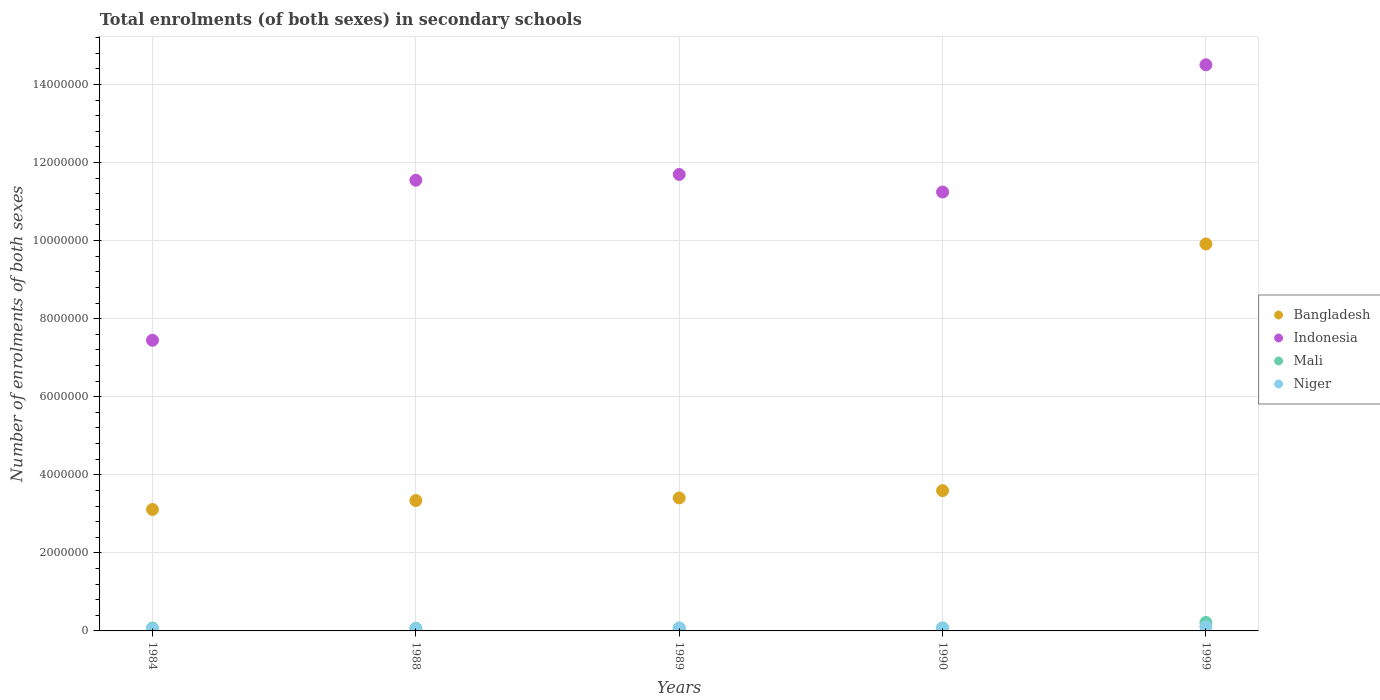How many different coloured dotlines are there?
Your answer should be very brief. 4. What is the number of enrolments in secondary schools in Indonesia in 1988?
Your answer should be very brief. 1.15e+07. Across all years, what is the maximum number of enrolments in secondary schools in Mali?
Provide a succinct answer. 2.18e+05. Across all years, what is the minimum number of enrolments in secondary schools in Bangladesh?
Ensure brevity in your answer.  3.11e+06. What is the total number of enrolments in secondary schools in Niger in the graph?
Offer a very short reply. 3.45e+05. What is the difference between the number of enrolments in secondary schools in Indonesia in 1988 and that in 1999?
Your response must be concise. -2.96e+06. What is the difference between the number of enrolments in secondary schools in Bangladesh in 1988 and the number of enrolments in secondary schools in Niger in 1989?
Give a very brief answer. 3.27e+06. What is the average number of enrolments in secondary schools in Indonesia per year?
Offer a very short reply. 1.13e+07. In the year 1984, what is the difference between the number of enrolments in secondary schools in Mali and number of enrolments in secondary schools in Indonesia?
Give a very brief answer. -7.37e+06. In how many years, is the number of enrolments in secondary schools in Indonesia greater than 12800000?
Offer a very short reply. 1. What is the ratio of the number of enrolments in secondary schools in Niger in 1984 to that in 1999?
Offer a very short reply. 0.45. Is the number of enrolments in secondary schools in Bangladesh in 1984 less than that in 1999?
Provide a succinct answer. Yes. Is the difference between the number of enrolments in secondary schools in Mali in 1990 and 1999 greater than the difference between the number of enrolments in secondary schools in Indonesia in 1990 and 1999?
Your answer should be compact. Yes. What is the difference between the highest and the second highest number of enrolments in secondary schools in Bangladesh?
Offer a terse response. 6.32e+06. What is the difference between the highest and the lowest number of enrolments in secondary schools in Mali?
Provide a succinct answer. 1.51e+05. Is the sum of the number of enrolments in secondary schools in Mali in 1988 and 1999 greater than the maximum number of enrolments in secondary schools in Bangladesh across all years?
Your answer should be very brief. No. Is the number of enrolments in secondary schools in Mali strictly greater than the number of enrolments in secondary schools in Niger over the years?
Ensure brevity in your answer.  Yes. How many dotlines are there?
Provide a succinct answer. 4. What is the difference between two consecutive major ticks on the Y-axis?
Provide a succinct answer. 2.00e+06. Does the graph contain grids?
Provide a short and direct response. Yes. Where does the legend appear in the graph?
Your response must be concise. Center right. How many legend labels are there?
Provide a succinct answer. 4. What is the title of the graph?
Provide a succinct answer. Total enrolments (of both sexes) in secondary schools. Does "Argentina" appear as one of the legend labels in the graph?
Provide a short and direct response. No. What is the label or title of the X-axis?
Offer a very short reply. Years. What is the label or title of the Y-axis?
Provide a short and direct response. Number of enrolments of both sexes. What is the Number of enrolments of both sexes of Bangladesh in 1984?
Give a very brief answer. 3.11e+06. What is the Number of enrolments of both sexes of Indonesia in 1984?
Keep it short and to the point. 7.45e+06. What is the Number of enrolments of both sexes in Mali in 1984?
Your answer should be very brief. 7.32e+04. What is the Number of enrolments of both sexes of Niger in 1984?
Keep it short and to the point. 4.72e+04. What is the Number of enrolments of both sexes in Bangladesh in 1988?
Provide a succinct answer. 3.34e+06. What is the Number of enrolments of both sexes in Indonesia in 1988?
Your answer should be very brief. 1.15e+07. What is the Number of enrolments of both sexes of Mali in 1988?
Give a very brief answer. 6.64e+04. What is the Number of enrolments of both sexes of Niger in 1988?
Ensure brevity in your answer.  5.85e+04. What is the Number of enrolments of both sexes of Bangladesh in 1989?
Ensure brevity in your answer.  3.41e+06. What is the Number of enrolments of both sexes of Indonesia in 1989?
Ensure brevity in your answer.  1.17e+07. What is the Number of enrolments of both sexes in Mali in 1989?
Offer a terse response. 7.52e+04. What is the Number of enrolments of both sexes in Niger in 1989?
Offer a terse response. 6.58e+04. What is the Number of enrolments of both sexes of Bangladesh in 1990?
Your answer should be very brief. 3.59e+06. What is the Number of enrolments of both sexes of Indonesia in 1990?
Your answer should be very brief. 1.12e+07. What is the Number of enrolments of both sexes of Mali in 1990?
Provide a short and direct response. 7.65e+04. What is the Number of enrolments of both sexes in Niger in 1990?
Your response must be concise. 6.84e+04. What is the Number of enrolments of both sexes in Bangladesh in 1999?
Offer a very short reply. 9.91e+06. What is the Number of enrolments of both sexes in Indonesia in 1999?
Offer a very short reply. 1.45e+07. What is the Number of enrolments of both sexes of Mali in 1999?
Keep it short and to the point. 2.18e+05. What is the Number of enrolments of both sexes in Niger in 1999?
Provide a short and direct response. 1.05e+05. Across all years, what is the maximum Number of enrolments of both sexes of Bangladesh?
Provide a succinct answer. 9.91e+06. Across all years, what is the maximum Number of enrolments of both sexes in Indonesia?
Provide a short and direct response. 1.45e+07. Across all years, what is the maximum Number of enrolments of both sexes of Mali?
Keep it short and to the point. 2.18e+05. Across all years, what is the maximum Number of enrolments of both sexes in Niger?
Give a very brief answer. 1.05e+05. Across all years, what is the minimum Number of enrolments of both sexes of Bangladesh?
Your answer should be very brief. 3.11e+06. Across all years, what is the minimum Number of enrolments of both sexes of Indonesia?
Ensure brevity in your answer.  7.45e+06. Across all years, what is the minimum Number of enrolments of both sexes in Mali?
Your response must be concise. 6.64e+04. Across all years, what is the minimum Number of enrolments of both sexes in Niger?
Provide a short and direct response. 4.72e+04. What is the total Number of enrolments of both sexes of Bangladesh in the graph?
Your answer should be compact. 2.34e+07. What is the total Number of enrolments of both sexes of Indonesia in the graph?
Your response must be concise. 5.64e+07. What is the total Number of enrolments of both sexes in Mali in the graph?
Provide a succinct answer. 5.09e+05. What is the total Number of enrolments of both sexes in Niger in the graph?
Keep it short and to the point. 3.45e+05. What is the difference between the Number of enrolments of both sexes of Bangladesh in 1984 and that in 1988?
Keep it short and to the point. -2.29e+05. What is the difference between the Number of enrolments of both sexes in Indonesia in 1984 and that in 1988?
Ensure brevity in your answer.  -4.10e+06. What is the difference between the Number of enrolments of both sexes in Mali in 1984 and that in 1988?
Offer a terse response. 6787. What is the difference between the Number of enrolments of both sexes of Niger in 1984 and that in 1988?
Your response must be concise. -1.13e+04. What is the difference between the Number of enrolments of both sexes of Bangladesh in 1984 and that in 1989?
Offer a very short reply. -2.95e+05. What is the difference between the Number of enrolments of both sexes in Indonesia in 1984 and that in 1989?
Make the answer very short. -4.25e+06. What is the difference between the Number of enrolments of both sexes of Mali in 1984 and that in 1989?
Offer a terse response. -1995. What is the difference between the Number of enrolments of both sexes in Niger in 1984 and that in 1989?
Offer a very short reply. -1.86e+04. What is the difference between the Number of enrolments of both sexes of Bangladesh in 1984 and that in 1990?
Give a very brief answer. -4.82e+05. What is the difference between the Number of enrolments of both sexes of Indonesia in 1984 and that in 1990?
Keep it short and to the point. -3.80e+06. What is the difference between the Number of enrolments of both sexes of Mali in 1984 and that in 1990?
Make the answer very short. -3283. What is the difference between the Number of enrolments of both sexes of Niger in 1984 and that in 1990?
Provide a short and direct response. -2.12e+04. What is the difference between the Number of enrolments of both sexes of Bangladesh in 1984 and that in 1999?
Offer a terse response. -6.80e+06. What is the difference between the Number of enrolments of both sexes of Indonesia in 1984 and that in 1999?
Make the answer very short. -7.06e+06. What is the difference between the Number of enrolments of both sexes in Mali in 1984 and that in 1999?
Your response must be concise. -1.44e+05. What is the difference between the Number of enrolments of both sexes of Niger in 1984 and that in 1999?
Offer a terse response. -5.77e+04. What is the difference between the Number of enrolments of both sexes in Bangladesh in 1988 and that in 1989?
Your response must be concise. -6.64e+04. What is the difference between the Number of enrolments of both sexes of Indonesia in 1988 and that in 1989?
Your response must be concise. -1.48e+05. What is the difference between the Number of enrolments of both sexes in Mali in 1988 and that in 1989?
Provide a succinct answer. -8782. What is the difference between the Number of enrolments of both sexes in Niger in 1988 and that in 1989?
Keep it short and to the point. -7327. What is the difference between the Number of enrolments of both sexes in Bangladesh in 1988 and that in 1990?
Keep it short and to the point. -2.53e+05. What is the difference between the Number of enrolments of both sexes in Indonesia in 1988 and that in 1990?
Offer a terse response. 3.02e+05. What is the difference between the Number of enrolments of both sexes in Mali in 1988 and that in 1990?
Offer a very short reply. -1.01e+04. What is the difference between the Number of enrolments of both sexes of Niger in 1988 and that in 1990?
Your answer should be compact. -9863. What is the difference between the Number of enrolments of both sexes in Bangladesh in 1988 and that in 1999?
Provide a succinct answer. -6.57e+06. What is the difference between the Number of enrolments of both sexes of Indonesia in 1988 and that in 1999?
Ensure brevity in your answer.  -2.96e+06. What is the difference between the Number of enrolments of both sexes of Mali in 1988 and that in 1999?
Provide a short and direct response. -1.51e+05. What is the difference between the Number of enrolments of both sexes of Niger in 1988 and that in 1999?
Keep it short and to the point. -4.64e+04. What is the difference between the Number of enrolments of both sexes of Bangladesh in 1989 and that in 1990?
Provide a succinct answer. -1.86e+05. What is the difference between the Number of enrolments of both sexes in Indonesia in 1989 and that in 1990?
Provide a short and direct response. 4.50e+05. What is the difference between the Number of enrolments of both sexes of Mali in 1989 and that in 1990?
Provide a succinct answer. -1288. What is the difference between the Number of enrolments of both sexes of Niger in 1989 and that in 1990?
Offer a very short reply. -2536. What is the difference between the Number of enrolments of both sexes in Bangladesh in 1989 and that in 1999?
Make the answer very short. -6.51e+06. What is the difference between the Number of enrolments of both sexes of Indonesia in 1989 and that in 1999?
Give a very brief answer. -2.81e+06. What is the difference between the Number of enrolments of both sexes in Mali in 1989 and that in 1999?
Your answer should be compact. -1.42e+05. What is the difference between the Number of enrolments of both sexes in Niger in 1989 and that in 1999?
Your answer should be very brief. -3.91e+04. What is the difference between the Number of enrolments of both sexes in Bangladesh in 1990 and that in 1999?
Keep it short and to the point. -6.32e+06. What is the difference between the Number of enrolments of both sexes of Indonesia in 1990 and that in 1999?
Provide a succinct answer. -3.26e+06. What is the difference between the Number of enrolments of both sexes in Mali in 1990 and that in 1999?
Your answer should be compact. -1.41e+05. What is the difference between the Number of enrolments of both sexes in Niger in 1990 and that in 1999?
Provide a short and direct response. -3.66e+04. What is the difference between the Number of enrolments of both sexes of Bangladesh in 1984 and the Number of enrolments of both sexes of Indonesia in 1988?
Offer a very short reply. -8.43e+06. What is the difference between the Number of enrolments of both sexes of Bangladesh in 1984 and the Number of enrolments of both sexes of Mali in 1988?
Your response must be concise. 3.04e+06. What is the difference between the Number of enrolments of both sexes of Bangladesh in 1984 and the Number of enrolments of both sexes of Niger in 1988?
Ensure brevity in your answer.  3.05e+06. What is the difference between the Number of enrolments of both sexes of Indonesia in 1984 and the Number of enrolments of both sexes of Mali in 1988?
Provide a short and direct response. 7.38e+06. What is the difference between the Number of enrolments of both sexes of Indonesia in 1984 and the Number of enrolments of both sexes of Niger in 1988?
Your response must be concise. 7.39e+06. What is the difference between the Number of enrolments of both sexes in Mali in 1984 and the Number of enrolments of both sexes in Niger in 1988?
Offer a terse response. 1.47e+04. What is the difference between the Number of enrolments of both sexes in Bangladesh in 1984 and the Number of enrolments of both sexes in Indonesia in 1989?
Ensure brevity in your answer.  -8.58e+06. What is the difference between the Number of enrolments of both sexes of Bangladesh in 1984 and the Number of enrolments of both sexes of Mali in 1989?
Your answer should be very brief. 3.04e+06. What is the difference between the Number of enrolments of both sexes in Bangladesh in 1984 and the Number of enrolments of both sexes in Niger in 1989?
Your response must be concise. 3.05e+06. What is the difference between the Number of enrolments of both sexes in Indonesia in 1984 and the Number of enrolments of both sexes in Mali in 1989?
Keep it short and to the point. 7.37e+06. What is the difference between the Number of enrolments of both sexes in Indonesia in 1984 and the Number of enrolments of both sexes in Niger in 1989?
Your answer should be very brief. 7.38e+06. What is the difference between the Number of enrolments of both sexes in Mali in 1984 and the Number of enrolments of both sexes in Niger in 1989?
Your answer should be very brief. 7402. What is the difference between the Number of enrolments of both sexes in Bangladesh in 1984 and the Number of enrolments of both sexes in Indonesia in 1990?
Offer a very short reply. -8.13e+06. What is the difference between the Number of enrolments of both sexes of Bangladesh in 1984 and the Number of enrolments of both sexes of Mali in 1990?
Your answer should be compact. 3.03e+06. What is the difference between the Number of enrolments of both sexes in Bangladesh in 1984 and the Number of enrolments of both sexes in Niger in 1990?
Make the answer very short. 3.04e+06. What is the difference between the Number of enrolments of both sexes in Indonesia in 1984 and the Number of enrolments of both sexes in Mali in 1990?
Your response must be concise. 7.37e+06. What is the difference between the Number of enrolments of both sexes in Indonesia in 1984 and the Number of enrolments of both sexes in Niger in 1990?
Your answer should be compact. 7.38e+06. What is the difference between the Number of enrolments of both sexes of Mali in 1984 and the Number of enrolments of both sexes of Niger in 1990?
Your response must be concise. 4866. What is the difference between the Number of enrolments of both sexes in Bangladesh in 1984 and the Number of enrolments of both sexes in Indonesia in 1999?
Your answer should be very brief. -1.14e+07. What is the difference between the Number of enrolments of both sexes in Bangladesh in 1984 and the Number of enrolments of both sexes in Mali in 1999?
Provide a short and direct response. 2.89e+06. What is the difference between the Number of enrolments of both sexes of Bangladesh in 1984 and the Number of enrolments of both sexes of Niger in 1999?
Keep it short and to the point. 3.01e+06. What is the difference between the Number of enrolments of both sexes of Indonesia in 1984 and the Number of enrolments of both sexes of Mali in 1999?
Give a very brief answer. 7.23e+06. What is the difference between the Number of enrolments of both sexes in Indonesia in 1984 and the Number of enrolments of both sexes in Niger in 1999?
Offer a very short reply. 7.34e+06. What is the difference between the Number of enrolments of both sexes in Mali in 1984 and the Number of enrolments of both sexes in Niger in 1999?
Your answer should be very brief. -3.17e+04. What is the difference between the Number of enrolments of both sexes in Bangladesh in 1988 and the Number of enrolments of both sexes in Indonesia in 1989?
Keep it short and to the point. -8.35e+06. What is the difference between the Number of enrolments of both sexes in Bangladesh in 1988 and the Number of enrolments of both sexes in Mali in 1989?
Give a very brief answer. 3.26e+06. What is the difference between the Number of enrolments of both sexes in Bangladesh in 1988 and the Number of enrolments of both sexes in Niger in 1989?
Your answer should be very brief. 3.27e+06. What is the difference between the Number of enrolments of both sexes of Indonesia in 1988 and the Number of enrolments of both sexes of Mali in 1989?
Your answer should be compact. 1.15e+07. What is the difference between the Number of enrolments of both sexes of Indonesia in 1988 and the Number of enrolments of both sexes of Niger in 1989?
Provide a short and direct response. 1.15e+07. What is the difference between the Number of enrolments of both sexes in Mali in 1988 and the Number of enrolments of both sexes in Niger in 1989?
Ensure brevity in your answer.  615. What is the difference between the Number of enrolments of both sexes of Bangladesh in 1988 and the Number of enrolments of both sexes of Indonesia in 1990?
Your answer should be very brief. -7.90e+06. What is the difference between the Number of enrolments of both sexes in Bangladesh in 1988 and the Number of enrolments of both sexes in Mali in 1990?
Offer a very short reply. 3.26e+06. What is the difference between the Number of enrolments of both sexes of Bangladesh in 1988 and the Number of enrolments of both sexes of Niger in 1990?
Provide a short and direct response. 3.27e+06. What is the difference between the Number of enrolments of both sexes in Indonesia in 1988 and the Number of enrolments of both sexes in Mali in 1990?
Make the answer very short. 1.15e+07. What is the difference between the Number of enrolments of both sexes in Indonesia in 1988 and the Number of enrolments of both sexes in Niger in 1990?
Your response must be concise. 1.15e+07. What is the difference between the Number of enrolments of both sexes of Mali in 1988 and the Number of enrolments of both sexes of Niger in 1990?
Offer a terse response. -1921. What is the difference between the Number of enrolments of both sexes of Bangladesh in 1988 and the Number of enrolments of both sexes of Indonesia in 1999?
Provide a succinct answer. -1.12e+07. What is the difference between the Number of enrolments of both sexes in Bangladesh in 1988 and the Number of enrolments of both sexes in Mali in 1999?
Offer a terse response. 3.12e+06. What is the difference between the Number of enrolments of both sexes of Bangladesh in 1988 and the Number of enrolments of both sexes of Niger in 1999?
Your answer should be very brief. 3.24e+06. What is the difference between the Number of enrolments of both sexes of Indonesia in 1988 and the Number of enrolments of both sexes of Mali in 1999?
Keep it short and to the point. 1.13e+07. What is the difference between the Number of enrolments of both sexes in Indonesia in 1988 and the Number of enrolments of both sexes in Niger in 1999?
Ensure brevity in your answer.  1.14e+07. What is the difference between the Number of enrolments of both sexes in Mali in 1988 and the Number of enrolments of both sexes in Niger in 1999?
Offer a terse response. -3.85e+04. What is the difference between the Number of enrolments of both sexes in Bangladesh in 1989 and the Number of enrolments of both sexes in Indonesia in 1990?
Give a very brief answer. -7.84e+06. What is the difference between the Number of enrolments of both sexes of Bangladesh in 1989 and the Number of enrolments of both sexes of Mali in 1990?
Ensure brevity in your answer.  3.33e+06. What is the difference between the Number of enrolments of both sexes in Bangladesh in 1989 and the Number of enrolments of both sexes in Niger in 1990?
Ensure brevity in your answer.  3.34e+06. What is the difference between the Number of enrolments of both sexes of Indonesia in 1989 and the Number of enrolments of both sexes of Mali in 1990?
Provide a succinct answer. 1.16e+07. What is the difference between the Number of enrolments of both sexes of Indonesia in 1989 and the Number of enrolments of both sexes of Niger in 1990?
Your answer should be compact. 1.16e+07. What is the difference between the Number of enrolments of both sexes in Mali in 1989 and the Number of enrolments of both sexes in Niger in 1990?
Your response must be concise. 6861. What is the difference between the Number of enrolments of both sexes in Bangladesh in 1989 and the Number of enrolments of both sexes in Indonesia in 1999?
Ensure brevity in your answer.  -1.11e+07. What is the difference between the Number of enrolments of both sexes of Bangladesh in 1989 and the Number of enrolments of both sexes of Mali in 1999?
Give a very brief answer. 3.19e+06. What is the difference between the Number of enrolments of both sexes of Bangladesh in 1989 and the Number of enrolments of both sexes of Niger in 1999?
Your answer should be very brief. 3.30e+06. What is the difference between the Number of enrolments of both sexes in Indonesia in 1989 and the Number of enrolments of both sexes in Mali in 1999?
Ensure brevity in your answer.  1.15e+07. What is the difference between the Number of enrolments of both sexes of Indonesia in 1989 and the Number of enrolments of both sexes of Niger in 1999?
Your answer should be compact. 1.16e+07. What is the difference between the Number of enrolments of both sexes in Mali in 1989 and the Number of enrolments of both sexes in Niger in 1999?
Keep it short and to the point. -2.97e+04. What is the difference between the Number of enrolments of both sexes in Bangladesh in 1990 and the Number of enrolments of both sexes in Indonesia in 1999?
Provide a short and direct response. -1.09e+07. What is the difference between the Number of enrolments of both sexes of Bangladesh in 1990 and the Number of enrolments of both sexes of Mali in 1999?
Make the answer very short. 3.38e+06. What is the difference between the Number of enrolments of both sexes in Bangladesh in 1990 and the Number of enrolments of both sexes in Niger in 1999?
Your answer should be compact. 3.49e+06. What is the difference between the Number of enrolments of both sexes of Indonesia in 1990 and the Number of enrolments of both sexes of Mali in 1999?
Offer a terse response. 1.10e+07. What is the difference between the Number of enrolments of both sexes of Indonesia in 1990 and the Number of enrolments of both sexes of Niger in 1999?
Provide a succinct answer. 1.11e+07. What is the difference between the Number of enrolments of both sexes of Mali in 1990 and the Number of enrolments of both sexes of Niger in 1999?
Your answer should be compact. -2.84e+04. What is the average Number of enrolments of both sexes in Bangladesh per year?
Your answer should be very brief. 4.67e+06. What is the average Number of enrolments of both sexes in Indonesia per year?
Offer a very short reply. 1.13e+07. What is the average Number of enrolments of both sexes of Mali per year?
Keep it short and to the point. 1.02e+05. What is the average Number of enrolments of both sexes of Niger per year?
Your answer should be very brief. 6.90e+04. In the year 1984, what is the difference between the Number of enrolments of both sexes in Bangladesh and Number of enrolments of both sexes in Indonesia?
Your answer should be very brief. -4.33e+06. In the year 1984, what is the difference between the Number of enrolments of both sexes of Bangladesh and Number of enrolments of both sexes of Mali?
Provide a succinct answer. 3.04e+06. In the year 1984, what is the difference between the Number of enrolments of both sexes of Bangladesh and Number of enrolments of both sexes of Niger?
Provide a short and direct response. 3.06e+06. In the year 1984, what is the difference between the Number of enrolments of both sexes in Indonesia and Number of enrolments of both sexes in Mali?
Keep it short and to the point. 7.37e+06. In the year 1984, what is the difference between the Number of enrolments of both sexes in Indonesia and Number of enrolments of both sexes in Niger?
Your answer should be very brief. 7.40e+06. In the year 1984, what is the difference between the Number of enrolments of both sexes in Mali and Number of enrolments of both sexes in Niger?
Give a very brief answer. 2.60e+04. In the year 1988, what is the difference between the Number of enrolments of both sexes in Bangladesh and Number of enrolments of both sexes in Indonesia?
Give a very brief answer. -8.20e+06. In the year 1988, what is the difference between the Number of enrolments of both sexes of Bangladesh and Number of enrolments of both sexes of Mali?
Keep it short and to the point. 3.27e+06. In the year 1988, what is the difference between the Number of enrolments of both sexes in Bangladesh and Number of enrolments of both sexes in Niger?
Make the answer very short. 3.28e+06. In the year 1988, what is the difference between the Number of enrolments of both sexes in Indonesia and Number of enrolments of both sexes in Mali?
Ensure brevity in your answer.  1.15e+07. In the year 1988, what is the difference between the Number of enrolments of both sexes in Indonesia and Number of enrolments of both sexes in Niger?
Provide a succinct answer. 1.15e+07. In the year 1988, what is the difference between the Number of enrolments of both sexes of Mali and Number of enrolments of both sexes of Niger?
Your response must be concise. 7942. In the year 1989, what is the difference between the Number of enrolments of both sexes in Bangladesh and Number of enrolments of both sexes in Indonesia?
Provide a short and direct response. -8.29e+06. In the year 1989, what is the difference between the Number of enrolments of both sexes of Bangladesh and Number of enrolments of both sexes of Mali?
Your answer should be very brief. 3.33e+06. In the year 1989, what is the difference between the Number of enrolments of both sexes of Bangladesh and Number of enrolments of both sexes of Niger?
Provide a succinct answer. 3.34e+06. In the year 1989, what is the difference between the Number of enrolments of both sexes in Indonesia and Number of enrolments of both sexes in Mali?
Provide a short and direct response. 1.16e+07. In the year 1989, what is the difference between the Number of enrolments of both sexes in Indonesia and Number of enrolments of both sexes in Niger?
Make the answer very short. 1.16e+07. In the year 1989, what is the difference between the Number of enrolments of both sexes of Mali and Number of enrolments of both sexes of Niger?
Provide a succinct answer. 9397. In the year 1990, what is the difference between the Number of enrolments of both sexes in Bangladesh and Number of enrolments of both sexes in Indonesia?
Provide a short and direct response. -7.65e+06. In the year 1990, what is the difference between the Number of enrolments of both sexes of Bangladesh and Number of enrolments of both sexes of Mali?
Provide a succinct answer. 3.52e+06. In the year 1990, what is the difference between the Number of enrolments of both sexes in Bangladesh and Number of enrolments of both sexes in Niger?
Keep it short and to the point. 3.52e+06. In the year 1990, what is the difference between the Number of enrolments of both sexes of Indonesia and Number of enrolments of both sexes of Mali?
Keep it short and to the point. 1.12e+07. In the year 1990, what is the difference between the Number of enrolments of both sexes in Indonesia and Number of enrolments of both sexes in Niger?
Offer a very short reply. 1.12e+07. In the year 1990, what is the difference between the Number of enrolments of both sexes of Mali and Number of enrolments of both sexes of Niger?
Your answer should be very brief. 8149. In the year 1999, what is the difference between the Number of enrolments of both sexes of Bangladesh and Number of enrolments of both sexes of Indonesia?
Offer a terse response. -4.59e+06. In the year 1999, what is the difference between the Number of enrolments of both sexes of Bangladesh and Number of enrolments of both sexes of Mali?
Ensure brevity in your answer.  9.69e+06. In the year 1999, what is the difference between the Number of enrolments of both sexes in Bangladesh and Number of enrolments of both sexes in Niger?
Your answer should be very brief. 9.81e+06. In the year 1999, what is the difference between the Number of enrolments of both sexes in Indonesia and Number of enrolments of both sexes in Mali?
Your response must be concise. 1.43e+07. In the year 1999, what is the difference between the Number of enrolments of both sexes of Indonesia and Number of enrolments of both sexes of Niger?
Your answer should be very brief. 1.44e+07. In the year 1999, what is the difference between the Number of enrolments of both sexes of Mali and Number of enrolments of both sexes of Niger?
Keep it short and to the point. 1.13e+05. What is the ratio of the Number of enrolments of both sexes of Bangladesh in 1984 to that in 1988?
Your answer should be very brief. 0.93. What is the ratio of the Number of enrolments of both sexes of Indonesia in 1984 to that in 1988?
Ensure brevity in your answer.  0.64. What is the ratio of the Number of enrolments of both sexes of Mali in 1984 to that in 1988?
Your answer should be compact. 1.1. What is the ratio of the Number of enrolments of both sexes of Niger in 1984 to that in 1988?
Provide a short and direct response. 0.81. What is the ratio of the Number of enrolments of both sexes of Bangladesh in 1984 to that in 1989?
Keep it short and to the point. 0.91. What is the ratio of the Number of enrolments of both sexes of Indonesia in 1984 to that in 1989?
Provide a succinct answer. 0.64. What is the ratio of the Number of enrolments of both sexes of Mali in 1984 to that in 1989?
Ensure brevity in your answer.  0.97. What is the ratio of the Number of enrolments of both sexes in Niger in 1984 to that in 1989?
Give a very brief answer. 0.72. What is the ratio of the Number of enrolments of both sexes in Bangladesh in 1984 to that in 1990?
Ensure brevity in your answer.  0.87. What is the ratio of the Number of enrolments of both sexes in Indonesia in 1984 to that in 1990?
Provide a succinct answer. 0.66. What is the ratio of the Number of enrolments of both sexes of Mali in 1984 to that in 1990?
Make the answer very short. 0.96. What is the ratio of the Number of enrolments of both sexes in Niger in 1984 to that in 1990?
Provide a succinct answer. 0.69. What is the ratio of the Number of enrolments of both sexes in Bangladesh in 1984 to that in 1999?
Make the answer very short. 0.31. What is the ratio of the Number of enrolments of both sexes in Indonesia in 1984 to that in 1999?
Provide a short and direct response. 0.51. What is the ratio of the Number of enrolments of both sexes of Mali in 1984 to that in 1999?
Offer a terse response. 0.34. What is the ratio of the Number of enrolments of both sexes of Niger in 1984 to that in 1999?
Offer a very short reply. 0.45. What is the ratio of the Number of enrolments of both sexes of Bangladesh in 1988 to that in 1989?
Give a very brief answer. 0.98. What is the ratio of the Number of enrolments of both sexes in Indonesia in 1988 to that in 1989?
Ensure brevity in your answer.  0.99. What is the ratio of the Number of enrolments of both sexes of Mali in 1988 to that in 1989?
Offer a terse response. 0.88. What is the ratio of the Number of enrolments of both sexes in Niger in 1988 to that in 1989?
Your response must be concise. 0.89. What is the ratio of the Number of enrolments of both sexes in Bangladesh in 1988 to that in 1990?
Give a very brief answer. 0.93. What is the ratio of the Number of enrolments of both sexes of Indonesia in 1988 to that in 1990?
Ensure brevity in your answer.  1.03. What is the ratio of the Number of enrolments of both sexes of Mali in 1988 to that in 1990?
Ensure brevity in your answer.  0.87. What is the ratio of the Number of enrolments of both sexes of Niger in 1988 to that in 1990?
Your response must be concise. 0.86. What is the ratio of the Number of enrolments of both sexes in Bangladesh in 1988 to that in 1999?
Keep it short and to the point. 0.34. What is the ratio of the Number of enrolments of both sexes in Indonesia in 1988 to that in 1999?
Offer a very short reply. 0.8. What is the ratio of the Number of enrolments of both sexes of Mali in 1988 to that in 1999?
Your answer should be very brief. 0.31. What is the ratio of the Number of enrolments of both sexes of Niger in 1988 to that in 1999?
Your response must be concise. 0.56. What is the ratio of the Number of enrolments of both sexes of Bangladesh in 1989 to that in 1990?
Give a very brief answer. 0.95. What is the ratio of the Number of enrolments of both sexes in Indonesia in 1989 to that in 1990?
Offer a terse response. 1.04. What is the ratio of the Number of enrolments of both sexes in Mali in 1989 to that in 1990?
Your response must be concise. 0.98. What is the ratio of the Number of enrolments of both sexes of Niger in 1989 to that in 1990?
Your answer should be compact. 0.96. What is the ratio of the Number of enrolments of both sexes in Bangladesh in 1989 to that in 1999?
Your response must be concise. 0.34. What is the ratio of the Number of enrolments of both sexes of Indonesia in 1989 to that in 1999?
Keep it short and to the point. 0.81. What is the ratio of the Number of enrolments of both sexes in Mali in 1989 to that in 1999?
Make the answer very short. 0.35. What is the ratio of the Number of enrolments of both sexes in Niger in 1989 to that in 1999?
Provide a short and direct response. 0.63. What is the ratio of the Number of enrolments of both sexes in Bangladesh in 1990 to that in 1999?
Make the answer very short. 0.36. What is the ratio of the Number of enrolments of both sexes in Indonesia in 1990 to that in 1999?
Make the answer very short. 0.78. What is the ratio of the Number of enrolments of both sexes of Mali in 1990 to that in 1999?
Offer a very short reply. 0.35. What is the ratio of the Number of enrolments of both sexes of Niger in 1990 to that in 1999?
Your answer should be very brief. 0.65. What is the difference between the highest and the second highest Number of enrolments of both sexes in Bangladesh?
Provide a succinct answer. 6.32e+06. What is the difference between the highest and the second highest Number of enrolments of both sexes of Indonesia?
Provide a succinct answer. 2.81e+06. What is the difference between the highest and the second highest Number of enrolments of both sexes of Mali?
Your answer should be very brief. 1.41e+05. What is the difference between the highest and the second highest Number of enrolments of both sexes in Niger?
Your answer should be compact. 3.66e+04. What is the difference between the highest and the lowest Number of enrolments of both sexes of Bangladesh?
Offer a very short reply. 6.80e+06. What is the difference between the highest and the lowest Number of enrolments of both sexes in Indonesia?
Your response must be concise. 7.06e+06. What is the difference between the highest and the lowest Number of enrolments of both sexes in Mali?
Provide a short and direct response. 1.51e+05. What is the difference between the highest and the lowest Number of enrolments of both sexes in Niger?
Ensure brevity in your answer.  5.77e+04. 